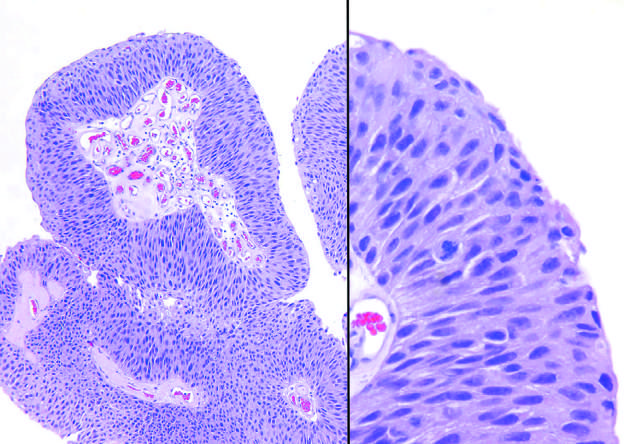how does higher magnification show slightly irregular nuclei?
Answer the question using a single word or phrase. With scattered mitotic figures 